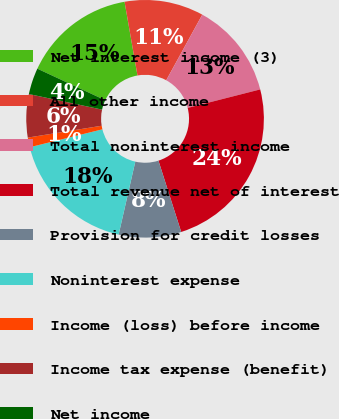Convert chart. <chart><loc_0><loc_0><loc_500><loc_500><pie_chart><fcel>Net interest income (3)<fcel>All other income<fcel>Total noninterest income<fcel>Total revenue net of interest<fcel>Provision for credit losses<fcel>Noninterest expense<fcel>Income (loss) before income<fcel>Income tax expense (benefit)<fcel>Net income<nl><fcel>15.31%<fcel>10.76%<fcel>13.03%<fcel>24.06%<fcel>8.49%<fcel>17.58%<fcel>1.32%<fcel>5.87%<fcel>3.59%<nl></chart> 